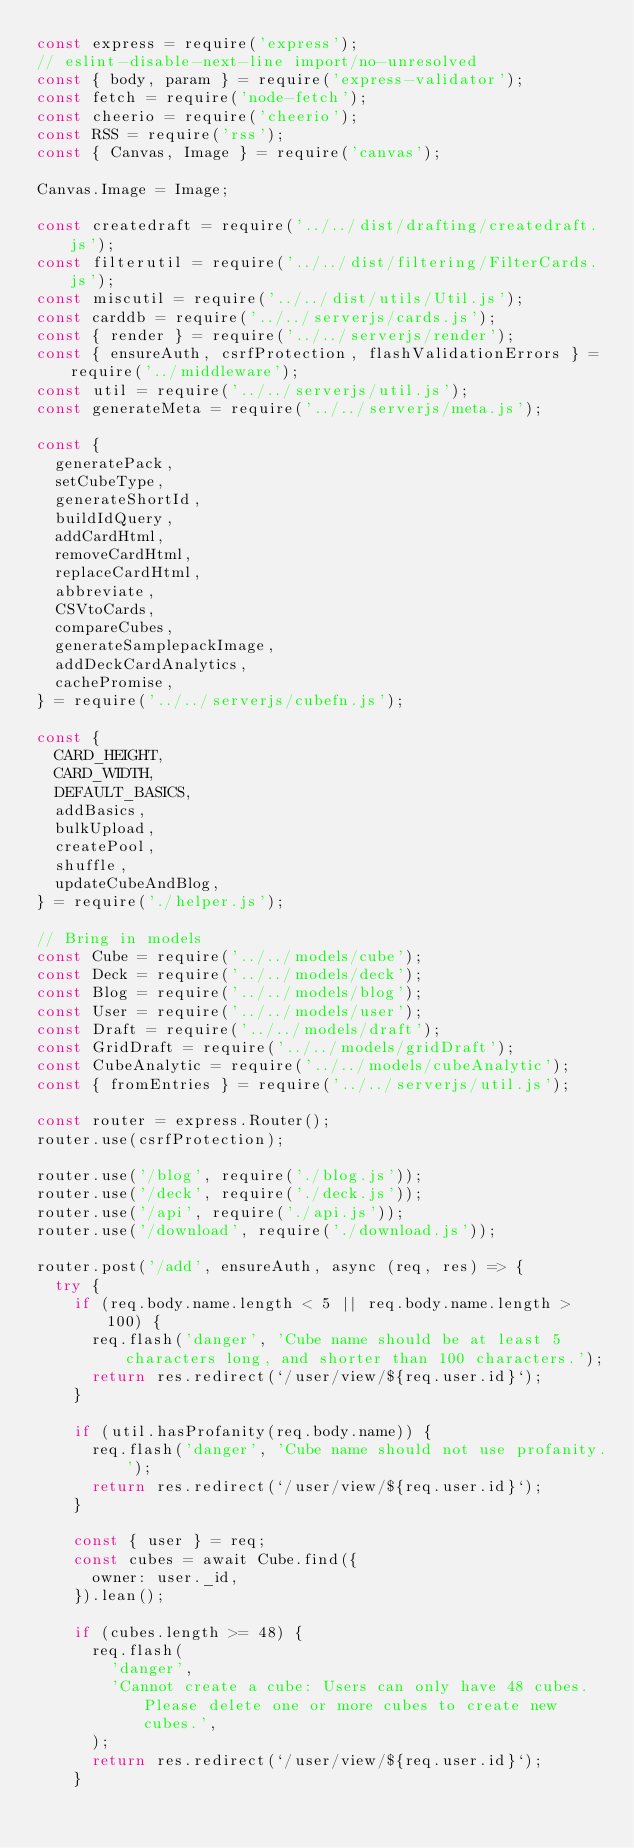Convert code to text. <code><loc_0><loc_0><loc_500><loc_500><_JavaScript_>const express = require('express');
// eslint-disable-next-line import/no-unresolved
const { body, param } = require('express-validator');
const fetch = require('node-fetch');
const cheerio = require('cheerio');
const RSS = require('rss');
const { Canvas, Image } = require('canvas');

Canvas.Image = Image;

const createdraft = require('../../dist/drafting/createdraft.js');
const filterutil = require('../../dist/filtering/FilterCards.js');
const miscutil = require('../../dist/utils/Util.js');
const carddb = require('../../serverjs/cards.js');
const { render } = require('../../serverjs/render');
const { ensureAuth, csrfProtection, flashValidationErrors } = require('../middleware');
const util = require('../../serverjs/util.js');
const generateMeta = require('../../serverjs/meta.js');

const {
  generatePack,
  setCubeType,
  generateShortId,
  buildIdQuery,
  addCardHtml,
  removeCardHtml,
  replaceCardHtml,
  abbreviate,
  CSVtoCards,
  compareCubes,
  generateSamplepackImage,
  addDeckCardAnalytics,
  cachePromise,
} = require('../../serverjs/cubefn.js');

const {
  CARD_HEIGHT,
  CARD_WIDTH,
  DEFAULT_BASICS,
  addBasics,
  bulkUpload,
  createPool,
  shuffle,
  updateCubeAndBlog,
} = require('./helper.js');

// Bring in models
const Cube = require('../../models/cube');
const Deck = require('../../models/deck');
const Blog = require('../../models/blog');
const User = require('../../models/user');
const Draft = require('../../models/draft');
const GridDraft = require('../../models/gridDraft');
const CubeAnalytic = require('../../models/cubeAnalytic');
const { fromEntries } = require('../../serverjs/util.js');

const router = express.Router();
router.use(csrfProtection);

router.use('/blog', require('./blog.js'));
router.use('/deck', require('./deck.js'));
router.use('/api', require('./api.js'));
router.use('/download', require('./download.js'));

router.post('/add', ensureAuth, async (req, res) => {
  try {
    if (req.body.name.length < 5 || req.body.name.length > 100) {
      req.flash('danger', 'Cube name should be at least 5 characters long, and shorter than 100 characters.');
      return res.redirect(`/user/view/${req.user.id}`);
    }

    if (util.hasProfanity(req.body.name)) {
      req.flash('danger', 'Cube name should not use profanity.');
      return res.redirect(`/user/view/${req.user.id}`);
    }

    const { user } = req;
    const cubes = await Cube.find({
      owner: user._id,
    }).lean();

    if (cubes.length >= 48) {
      req.flash(
        'danger',
        'Cannot create a cube: Users can only have 48 cubes. Please delete one or more cubes to create new cubes.',
      );
      return res.redirect(`/user/view/${req.user.id}`);
    }
</code> 